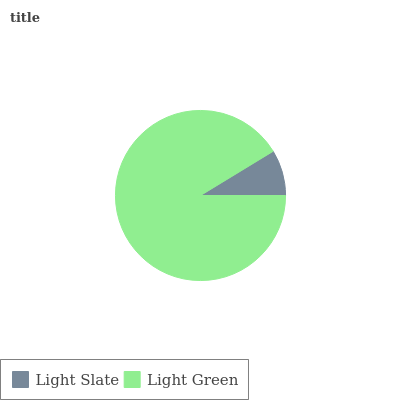Is Light Slate the minimum?
Answer yes or no. Yes. Is Light Green the maximum?
Answer yes or no. Yes. Is Light Green the minimum?
Answer yes or no. No. Is Light Green greater than Light Slate?
Answer yes or no. Yes. Is Light Slate less than Light Green?
Answer yes or no. Yes. Is Light Slate greater than Light Green?
Answer yes or no. No. Is Light Green less than Light Slate?
Answer yes or no. No. Is Light Green the high median?
Answer yes or no. Yes. Is Light Slate the low median?
Answer yes or no. Yes. Is Light Slate the high median?
Answer yes or no. No. Is Light Green the low median?
Answer yes or no. No. 